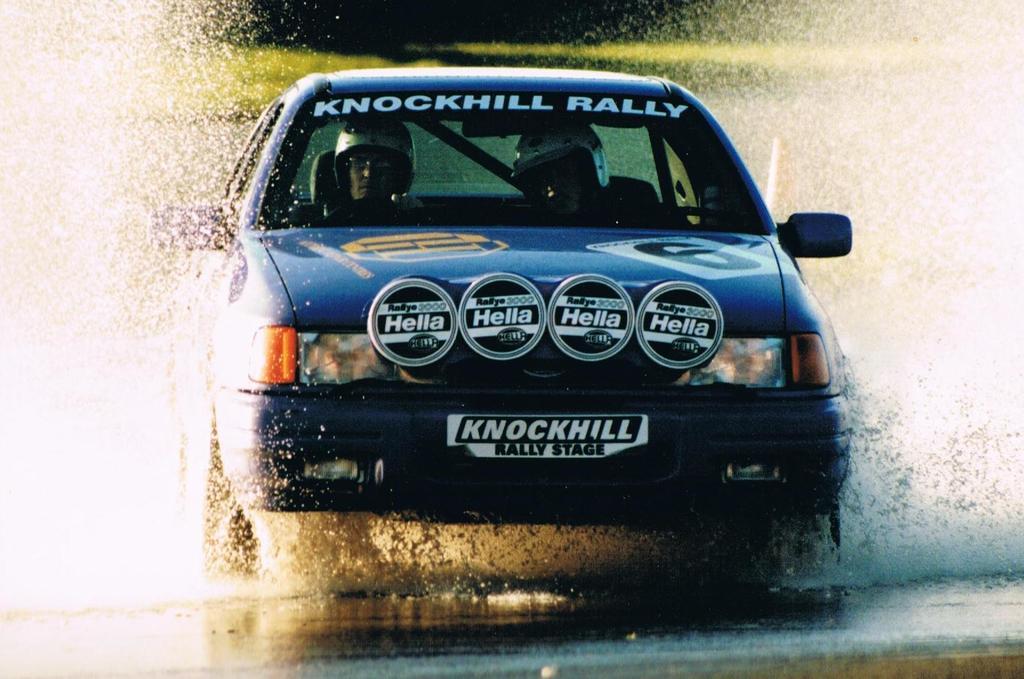Describe this image in one or two sentences. In this picture there is a car on the road. There are two persons sitting inside the car and there is a text on the car. At the back there is grass. At the bottom there is a road and there is water. 